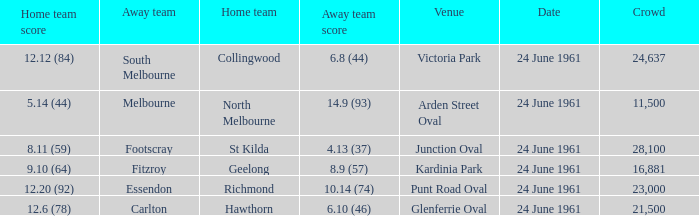Who was the home team that scored 12.6 (78)? Hawthorn. Parse the table in full. {'header': ['Home team score', 'Away team', 'Home team', 'Away team score', 'Venue', 'Date', 'Crowd'], 'rows': [['12.12 (84)', 'South Melbourne', 'Collingwood', '6.8 (44)', 'Victoria Park', '24 June 1961', '24,637'], ['5.14 (44)', 'Melbourne', 'North Melbourne', '14.9 (93)', 'Arden Street Oval', '24 June 1961', '11,500'], ['8.11 (59)', 'Footscray', 'St Kilda', '4.13 (37)', 'Junction Oval', '24 June 1961', '28,100'], ['9.10 (64)', 'Fitzroy', 'Geelong', '8.9 (57)', 'Kardinia Park', '24 June 1961', '16,881'], ['12.20 (92)', 'Essendon', 'Richmond', '10.14 (74)', 'Punt Road Oval', '24 June 1961', '23,000'], ['12.6 (78)', 'Carlton', 'Hawthorn', '6.10 (46)', 'Glenferrie Oval', '24 June 1961', '21,500']]} 